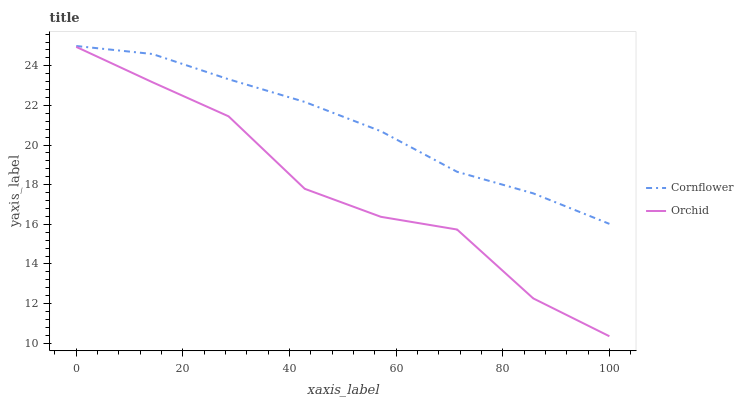Does Orchid have the maximum area under the curve?
Answer yes or no. No. Is Orchid the smoothest?
Answer yes or no. No. Does Orchid have the highest value?
Answer yes or no. No. Is Orchid less than Cornflower?
Answer yes or no. Yes. Is Cornflower greater than Orchid?
Answer yes or no. Yes. Does Orchid intersect Cornflower?
Answer yes or no. No. 